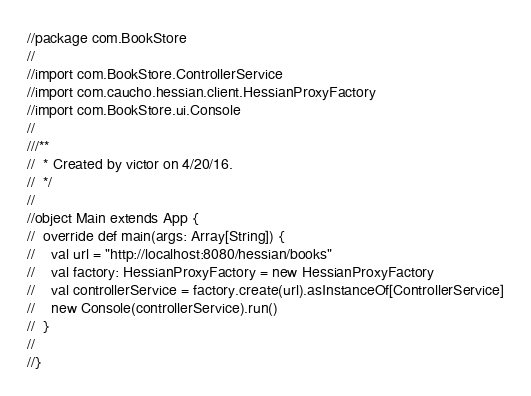<code> <loc_0><loc_0><loc_500><loc_500><_Scala_>//package com.BookStore
//
//import com.BookStore.ControllerService
//import com.caucho.hessian.client.HessianProxyFactory
//import com.BookStore.ui.Console
//
///**
//  * Created by victor on 4/20/16.
//  */
//
//object Main extends App {
//  override def main(args: Array[String]) {
//    val url = "http://localhost:8080/hessian/books"
//    val factory: HessianProxyFactory = new HessianProxyFactory
//    val controllerService = factory.create(url).asInstanceOf[ControllerService]
//    new Console(controllerService).run()
//  }
//
//}
</code> 